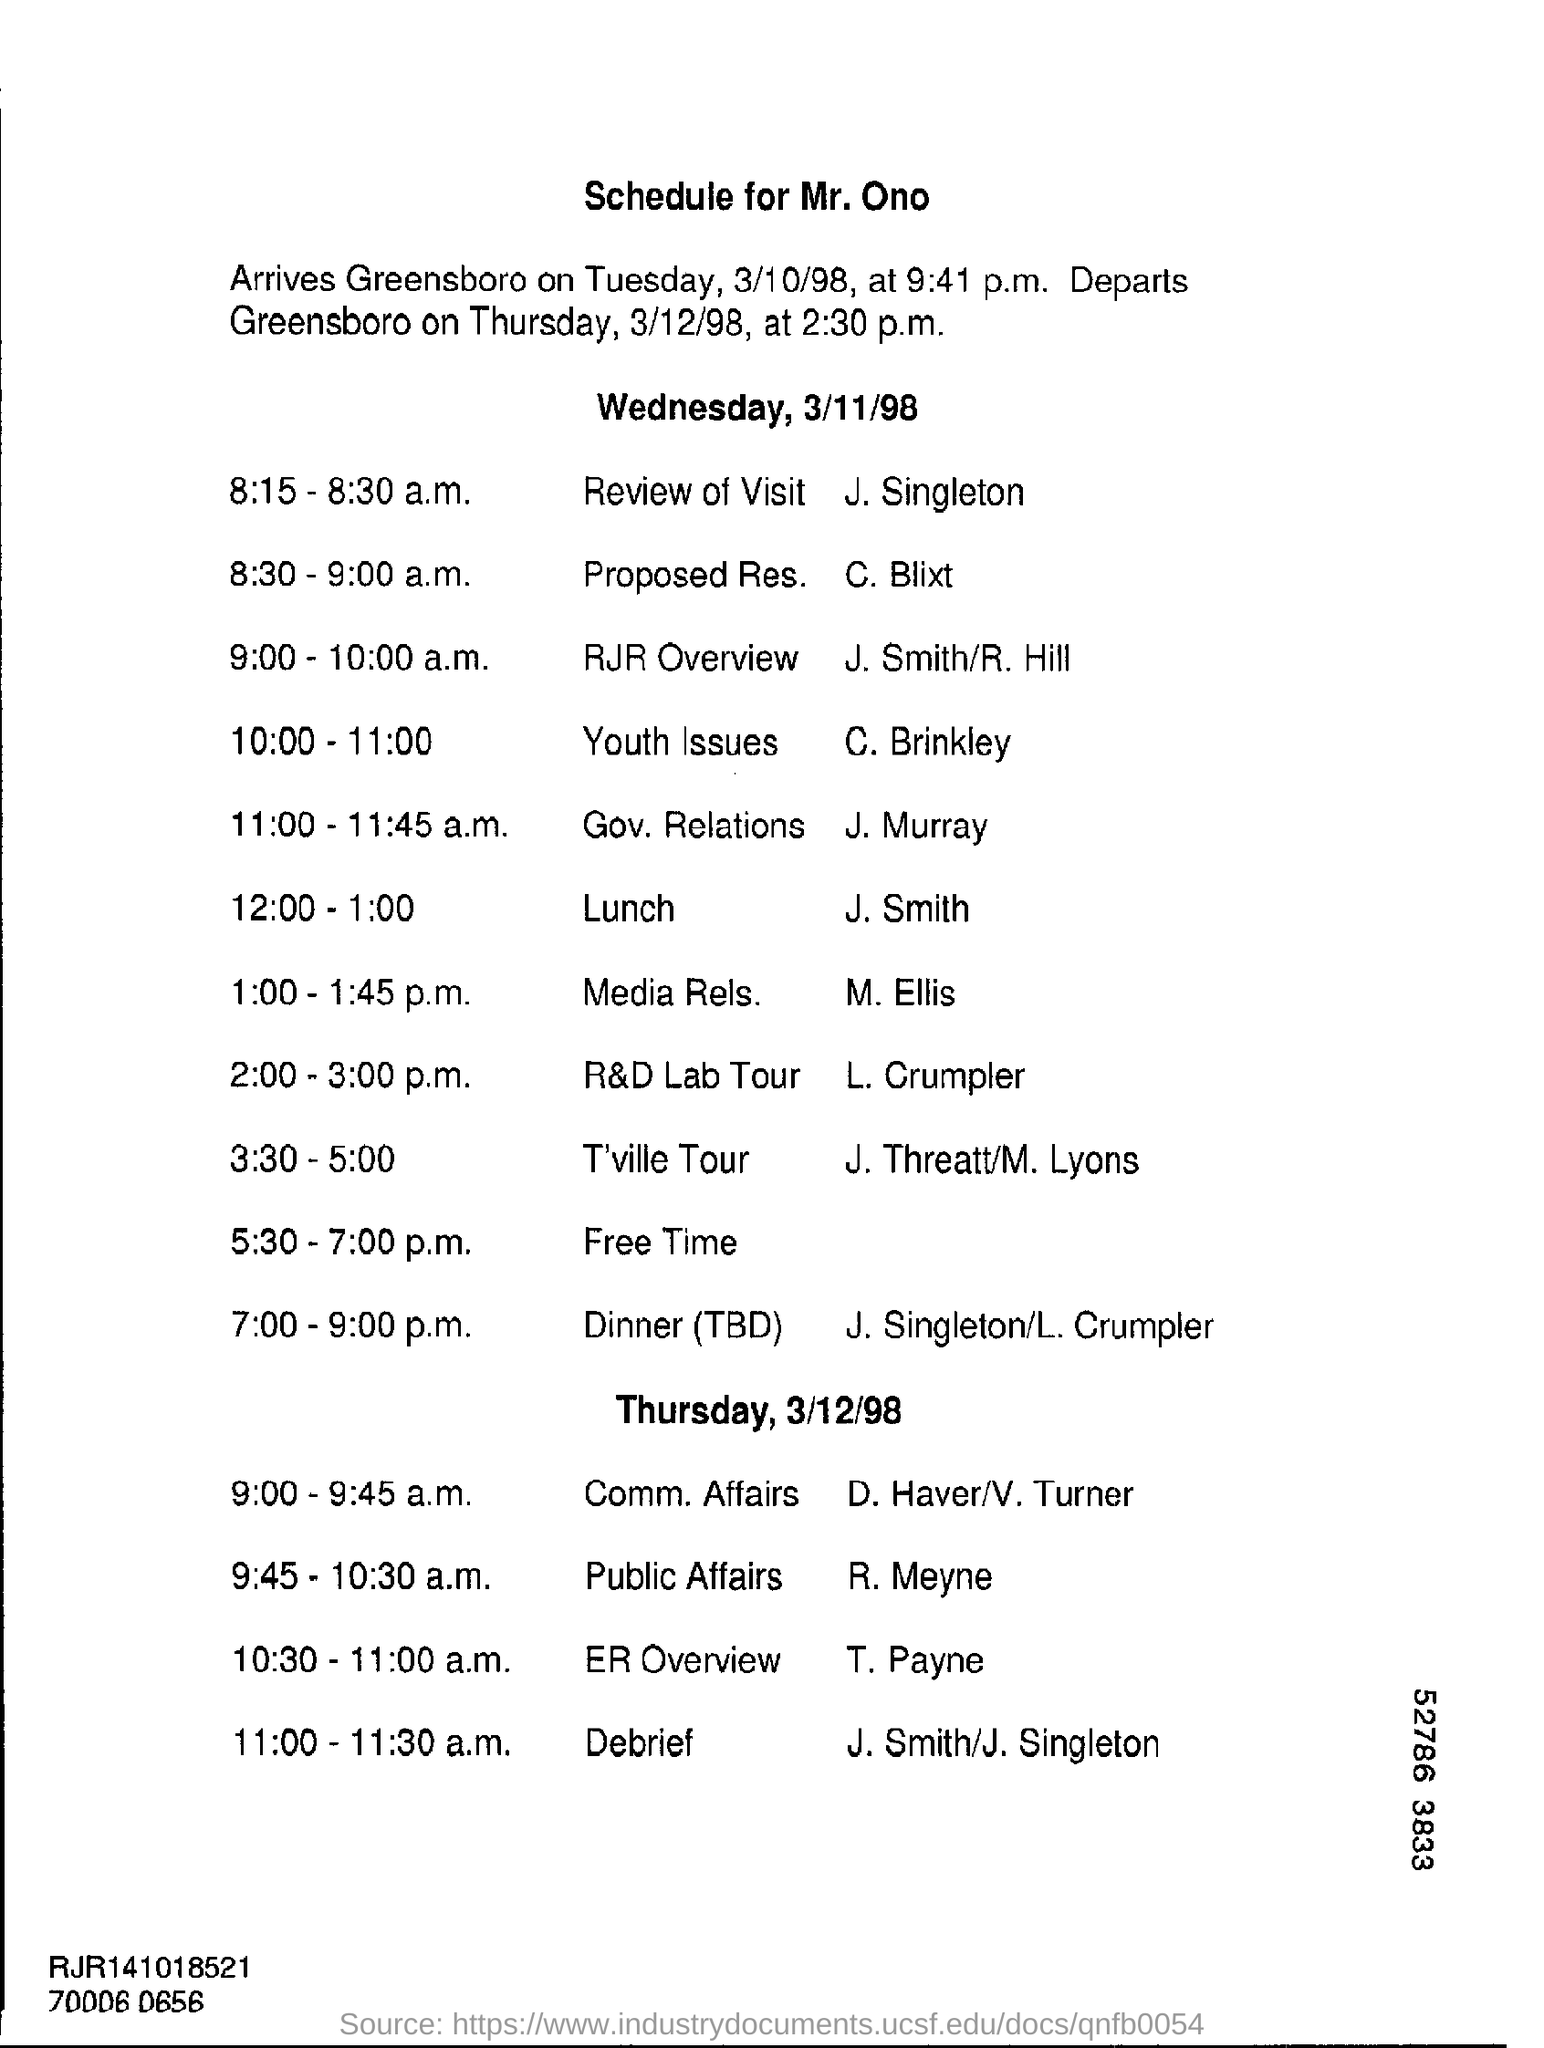This schedule is for whom?
Your response must be concise. Mr. Ono. When did Mr. Ono arrived at Greensboro?
Offer a terse response. Tuesday, 3/10/98. What are the timings of Review of visit?
Provide a succinct answer. 8:15-8:30 a.m. What will take place from 12:00-1:00?
Provide a succinct answer. LUNCH. 